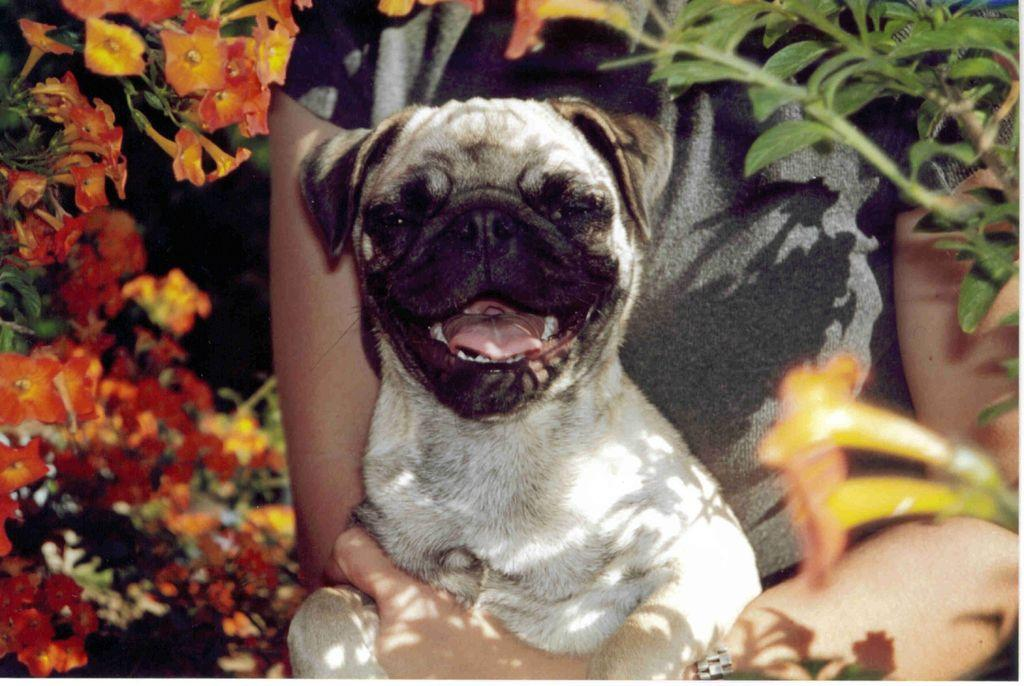What is the main subject of the image? There is a person in the image. What is the person doing in the image? The person is holding a dog with their hands. What other living organisms can be seen in the image? There are flowers and plants present in the image. What type of steel is visible in the image? There is no steel present in the image. How many flies can be seen in the image? There are no flies present in the image. 